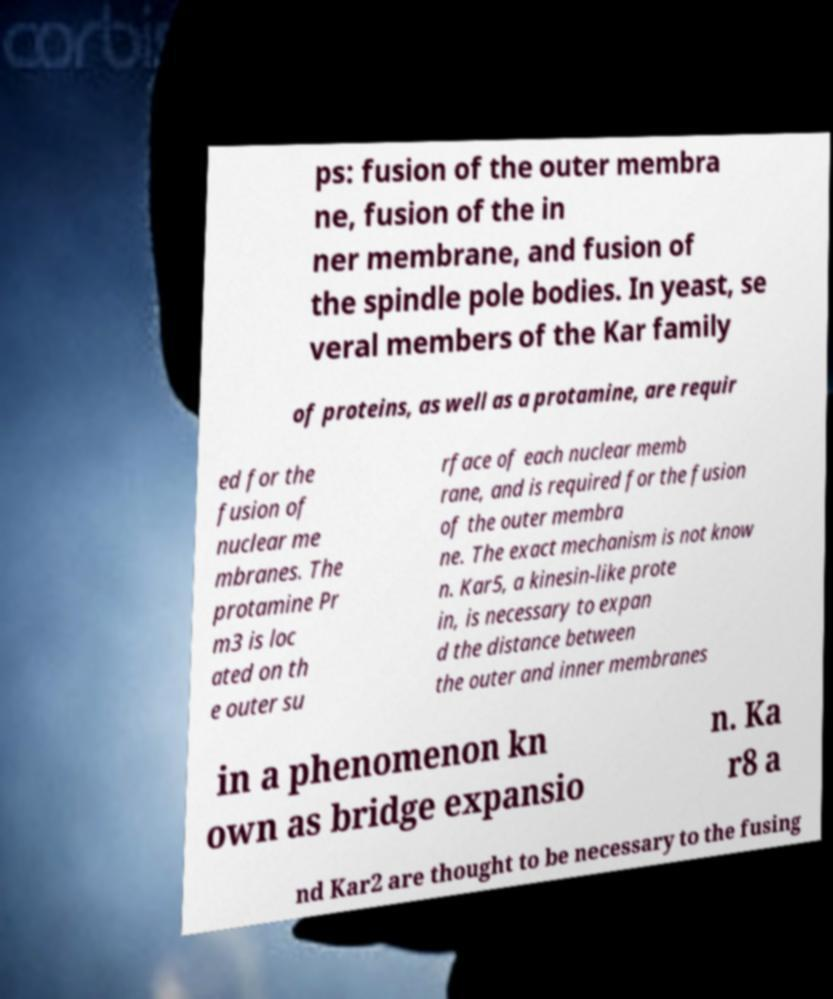Could you assist in decoding the text presented in this image and type it out clearly? ps: fusion of the outer membra ne, fusion of the in ner membrane, and fusion of the spindle pole bodies. In yeast, se veral members of the Kar family of proteins, as well as a protamine, are requir ed for the fusion of nuclear me mbranes. The protamine Pr m3 is loc ated on th e outer su rface of each nuclear memb rane, and is required for the fusion of the outer membra ne. The exact mechanism is not know n. Kar5, a kinesin-like prote in, is necessary to expan d the distance between the outer and inner membranes in a phenomenon kn own as bridge expansio n. Ka r8 a nd Kar2 are thought to be necessary to the fusing 